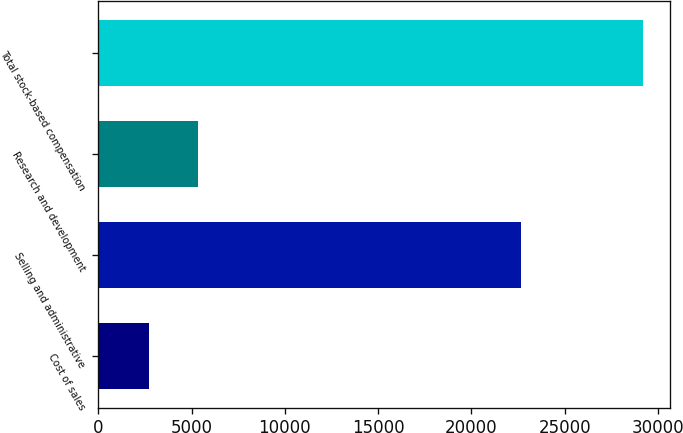Convert chart to OTSL. <chart><loc_0><loc_0><loc_500><loc_500><bar_chart><fcel>Cost of sales<fcel>Selling and administrative<fcel>Research and development<fcel>Total stock-based compensation<nl><fcel>2694<fcel>22679<fcel>5342.9<fcel>29183<nl></chart> 